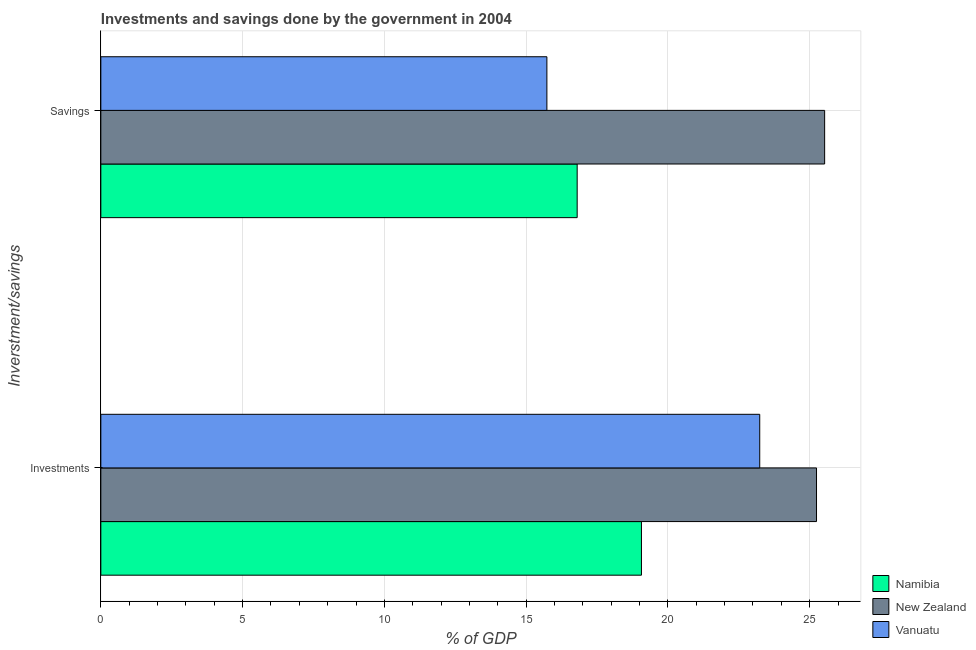How many groups of bars are there?
Make the answer very short. 2. Are the number of bars on each tick of the Y-axis equal?
Your answer should be compact. Yes. How many bars are there on the 1st tick from the bottom?
Give a very brief answer. 3. What is the label of the 1st group of bars from the top?
Provide a short and direct response. Savings. What is the investments of government in Vanuatu?
Keep it short and to the point. 23.24. Across all countries, what is the maximum savings of government?
Your answer should be compact. 25.53. Across all countries, what is the minimum savings of government?
Make the answer very short. 15.73. In which country was the savings of government maximum?
Your response must be concise. New Zealand. In which country was the savings of government minimum?
Your response must be concise. Vanuatu. What is the total savings of government in the graph?
Offer a very short reply. 58.06. What is the difference between the savings of government in New Zealand and that in Namibia?
Provide a short and direct response. 8.73. What is the difference between the investments of government in New Zealand and the savings of government in Namibia?
Your answer should be compact. 8.44. What is the average investments of government per country?
Give a very brief answer. 22.52. What is the difference between the savings of government and investments of government in New Zealand?
Keep it short and to the point. 0.29. In how many countries, is the investments of government greater than 18 %?
Provide a succinct answer. 3. What is the ratio of the savings of government in Vanuatu to that in New Zealand?
Provide a succinct answer. 0.62. Is the investments of government in New Zealand less than that in Namibia?
Provide a short and direct response. No. What does the 3rd bar from the top in Savings represents?
Give a very brief answer. Namibia. What does the 1st bar from the bottom in Savings represents?
Ensure brevity in your answer.  Namibia. How many bars are there?
Make the answer very short. 6. Are all the bars in the graph horizontal?
Keep it short and to the point. Yes. How many countries are there in the graph?
Provide a short and direct response. 3. Does the graph contain grids?
Your response must be concise. Yes. What is the title of the graph?
Offer a very short reply. Investments and savings done by the government in 2004. What is the label or title of the X-axis?
Make the answer very short. % of GDP. What is the label or title of the Y-axis?
Give a very brief answer. Inverstment/savings. What is the % of GDP of Namibia in Investments?
Make the answer very short. 19.07. What is the % of GDP in New Zealand in Investments?
Your answer should be compact. 25.24. What is the % of GDP of Vanuatu in Investments?
Provide a short and direct response. 23.24. What is the % of GDP of Namibia in Savings?
Your answer should be very brief. 16.8. What is the % of GDP in New Zealand in Savings?
Offer a terse response. 25.53. What is the % of GDP in Vanuatu in Savings?
Keep it short and to the point. 15.73. Across all Inverstment/savings, what is the maximum % of GDP in Namibia?
Keep it short and to the point. 19.07. Across all Inverstment/savings, what is the maximum % of GDP in New Zealand?
Your answer should be very brief. 25.53. Across all Inverstment/savings, what is the maximum % of GDP of Vanuatu?
Keep it short and to the point. 23.24. Across all Inverstment/savings, what is the minimum % of GDP of Namibia?
Provide a succinct answer. 16.8. Across all Inverstment/savings, what is the minimum % of GDP of New Zealand?
Keep it short and to the point. 25.24. Across all Inverstment/savings, what is the minimum % of GDP of Vanuatu?
Make the answer very short. 15.73. What is the total % of GDP in Namibia in the graph?
Your answer should be very brief. 35.87. What is the total % of GDP of New Zealand in the graph?
Ensure brevity in your answer.  50.77. What is the total % of GDP in Vanuatu in the graph?
Provide a succinct answer. 38.97. What is the difference between the % of GDP of Namibia in Investments and that in Savings?
Give a very brief answer. 2.27. What is the difference between the % of GDP in New Zealand in Investments and that in Savings?
Provide a short and direct response. -0.29. What is the difference between the % of GDP of Vanuatu in Investments and that in Savings?
Provide a short and direct response. 7.51. What is the difference between the % of GDP in Namibia in Investments and the % of GDP in New Zealand in Savings?
Provide a short and direct response. -6.46. What is the difference between the % of GDP of Namibia in Investments and the % of GDP of Vanuatu in Savings?
Give a very brief answer. 3.34. What is the difference between the % of GDP of New Zealand in Investments and the % of GDP of Vanuatu in Savings?
Make the answer very short. 9.51. What is the average % of GDP of Namibia per Inverstment/savings?
Provide a short and direct response. 17.93. What is the average % of GDP of New Zealand per Inverstment/savings?
Keep it short and to the point. 25.38. What is the average % of GDP in Vanuatu per Inverstment/savings?
Your answer should be very brief. 19.49. What is the difference between the % of GDP in Namibia and % of GDP in New Zealand in Investments?
Your response must be concise. -6.17. What is the difference between the % of GDP in Namibia and % of GDP in Vanuatu in Investments?
Provide a succinct answer. -4.17. What is the difference between the % of GDP of New Zealand and % of GDP of Vanuatu in Investments?
Make the answer very short. 2. What is the difference between the % of GDP of Namibia and % of GDP of New Zealand in Savings?
Provide a succinct answer. -8.73. What is the difference between the % of GDP of Namibia and % of GDP of Vanuatu in Savings?
Make the answer very short. 1.07. What is the difference between the % of GDP of New Zealand and % of GDP of Vanuatu in Savings?
Your response must be concise. 9.8. What is the ratio of the % of GDP in Namibia in Investments to that in Savings?
Your answer should be very brief. 1.14. What is the ratio of the % of GDP of New Zealand in Investments to that in Savings?
Make the answer very short. 0.99. What is the ratio of the % of GDP of Vanuatu in Investments to that in Savings?
Offer a very short reply. 1.48. What is the difference between the highest and the second highest % of GDP in Namibia?
Provide a succinct answer. 2.27. What is the difference between the highest and the second highest % of GDP in New Zealand?
Keep it short and to the point. 0.29. What is the difference between the highest and the second highest % of GDP in Vanuatu?
Offer a very short reply. 7.51. What is the difference between the highest and the lowest % of GDP in Namibia?
Offer a very short reply. 2.27. What is the difference between the highest and the lowest % of GDP of New Zealand?
Provide a short and direct response. 0.29. What is the difference between the highest and the lowest % of GDP of Vanuatu?
Offer a terse response. 7.51. 